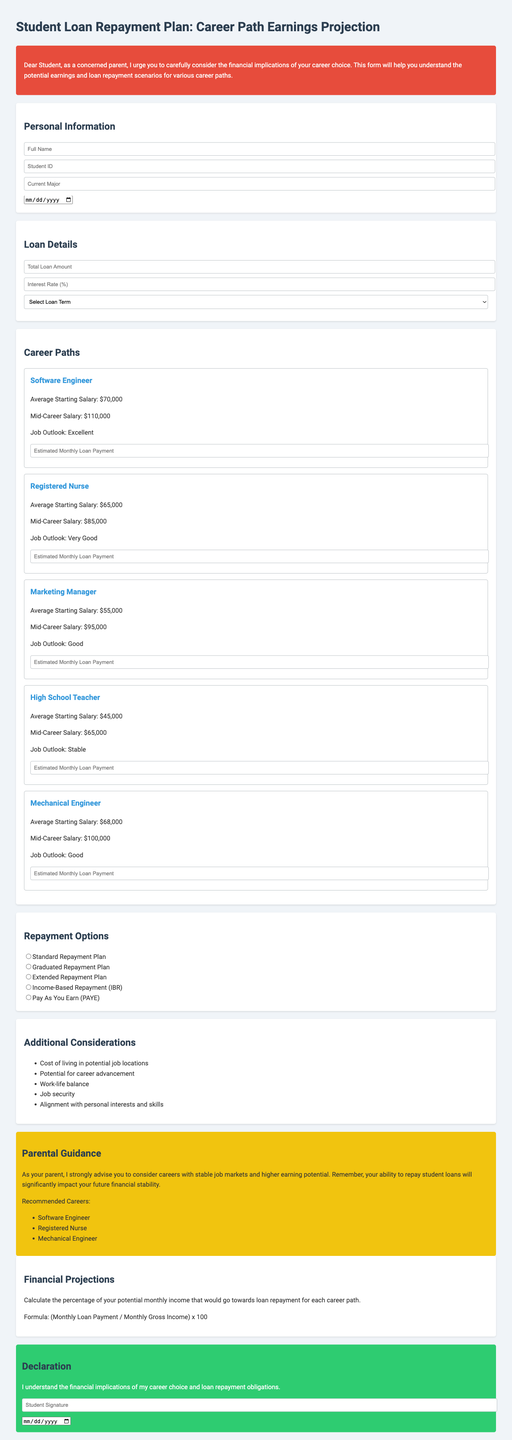What is the title of the form? The title of the form is provided at the top of the document.
Answer: Student Loan Repayment Plan: Career Path Earnings Projection What is the average starting salary for a Registered Nurse? The average starting salary for this career path is specified in the career sections.
Answer: $65,000 What is one of the repayment options listed in the document? The document lists several repayment options as part of the repayment section.
Answer: Standard Repayment Plan What is the mid-career salary for a Software Engineer? The mid-career salary is indicated alongside the career paths in the document.
Answer: $110,000 Which career has the best job outlook? The job outlooks are labeled for each career, indicating their future prospects.
Answer: Excellent What is the estimated monthly loan payment field used for? This field allows the student to project their loan payment based on their career salary.
Answer: To estimate monthly loan payment What is one of the additional considerations mentioned? The document lists various factors students should take into account when choosing a career.
Answer: Cost of living in potential job locations Which career is recommended for its higher earning potential? The parental guidance section suggests specific careers based on market stability and earning potential.
Answer: Software Engineer What does the declaration section require? The declaration is a statement that the student must acknowledge regarding their understanding of financial obligations.
Answer: Student Signature 